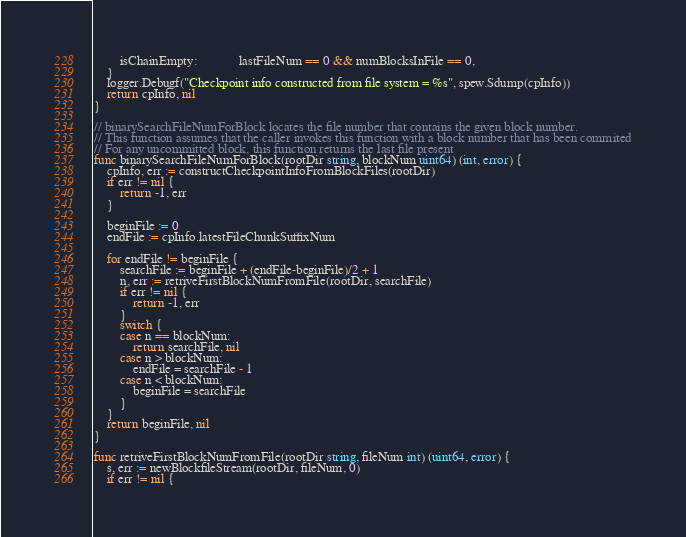<code> <loc_0><loc_0><loc_500><loc_500><_Go_>		isChainEmpty:             lastFileNum == 0 && numBlocksInFile == 0,
	}
	logger.Debugf("Checkpoint info constructed from file system = %s", spew.Sdump(cpInfo))
	return cpInfo, nil
}

// binarySearchFileNumForBlock locates the file number that contains the given block number.
// This function assumes that the caller invokes this function with a block number that has been commited
// For any uncommitted block, this function returns the last file present
func binarySearchFileNumForBlock(rootDir string, blockNum uint64) (int, error) {
	cpInfo, err := constructCheckpointInfoFromBlockFiles(rootDir)
	if err != nil {
		return -1, err
	}

	beginFile := 0
	endFile := cpInfo.latestFileChunkSuffixNum

	for endFile != beginFile {
		searchFile := beginFile + (endFile-beginFile)/2 + 1
		n, err := retriveFirstBlockNumFromFile(rootDir, searchFile)
		if err != nil {
			return -1, err
		}
		switch {
		case n == blockNum:
			return searchFile, nil
		case n > blockNum:
			endFile = searchFile - 1
		case n < blockNum:
			beginFile = searchFile
		}
	}
	return beginFile, nil
}

func retriveFirstBlockNumFromFile(rootDir string, fileNum int) (uint64, error) {
	s, err := newBlockfileStream(rootDir, fileNum, 0)
	if err != nil {</code> 